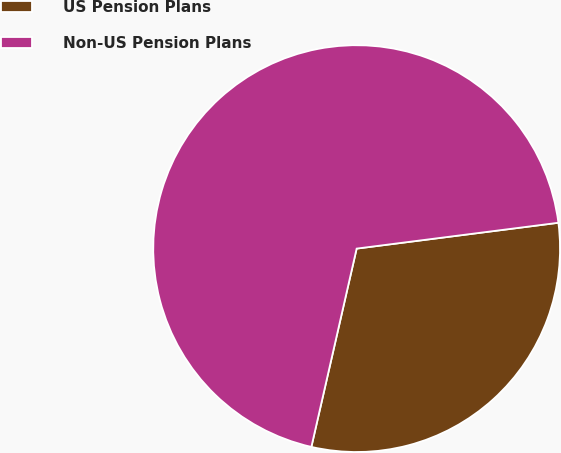Convert chart to OTSL. <chart><loc_0><loc_0><loc_500><loc_500><pie_chart><fcel>US Pension Plans<fcel>Non-US Pension Plans<nl><fcel>30.6%<fcel>69.4%<nl></chart> 